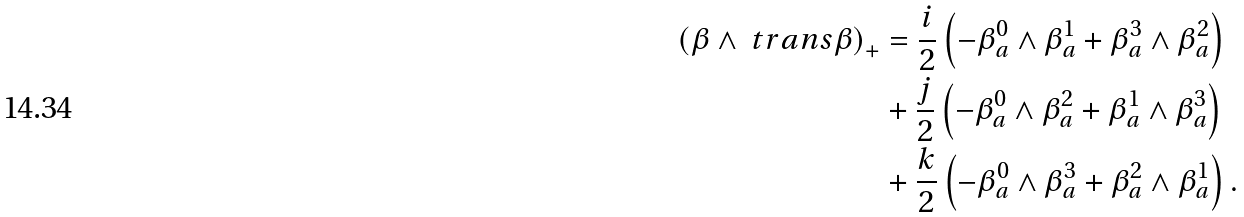Convert formula to latex. <formula><loc_0><loc_0><loc_500><loc_500>\left ( \beta \wedge \ t r a n s { \beta } \right ) _ { + } & = \frac { i } { 2 } \left ( - \beta ^ { 0 } _ { a } \wedge \beta ^ { 1 } _ { a } + \beta ^ { 3 } _ { a } \wedge \beta ^ { 2 } _ { a } \right ) \\ & + \frac { j } { 2 } \left ( - \beta ^ { 0 } _ { a } \wedge \beta ^ { 2 } _ { a } + \beta ^ { 1 } _ { a } \wedge \beta ^ { 3 } _ { a } \right ) \\ & + \frac { k } { 2 } \left ( - \beta ^ { 0 } _ { a } \wedge \beta ^ { 3 } _ { a } + \beta ^ { 2 } _ { a } \wedge \beta ^ { 1 } _ { a } \right ) .</formula> 